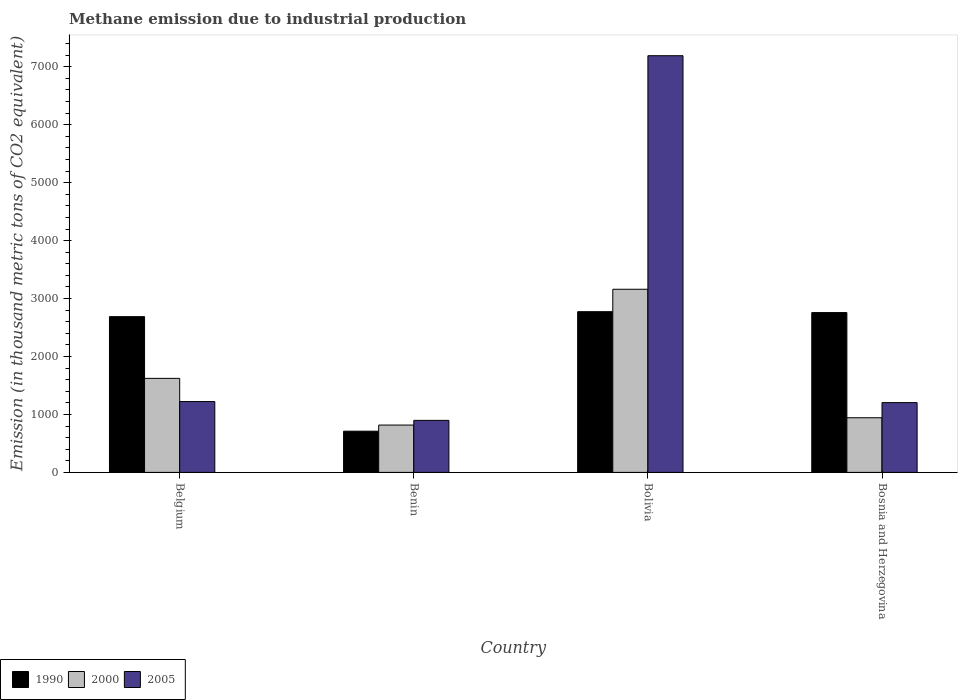How many groups of bars are there?
Your response must be concise. 4. Are the number of bars per tick equal to the number of legend labels?
Provide a short and direct response. Yes. In how many cases, is the number of bars for a given country not equal to the number of legend labels?
Your answer should be very brief. 0. What is the amount of methane emitted in 2000 in Benin?
Provide a succinct answer. 817.2. Across all countries, what is the maximum amount of methane emitted in 2000?
Provide a short and direct response. 3160.9. Across all countries, what is the minimum amount of methane emitted in 1990?
Your response must be concise. 711.4. In which country was the amount of methane emitted in 1990 minimum?
Make the answer very short. Benin. What is the total amount of methane emitted in 2000 in the graph?
Make the answer very short. 6544.3. What is the difference between the amount of methane emitted in 2000 in Benin and that in Bolivia?
Provide a short and direct response. -2343.7. What is the difference between the amount of methane emitted in 2000 in Bosnia and Herzegovina and the amount of methane emitted in 2005 in Benin?
Make the answer very short. 45.1. What is the average amount of methane emitted in 2000 per country?
Make the answer very short. 1636.08. What is the difference between the amount of methane emitted of/in 2000 and amount of methane emitted of/in 2005 in Bosnia and Herzegovina?
Keep it short and to the point. -261.1. In how many countries, is the amount of methane emitted in 1990 greater than 1600 thousand metric tons?
Ensure brevity in your answer.  3. What is the ratio of the amount of methane emitted in 2000 in Belgium to that in Benin?
Your response must be concise. 1.99. Is the amount of methane emitted in 1990 in Benin less than that in Bosnia and Herzegovina?
Your response must be concise. Yes. What is the difference between the highest and the second highest amount of methane emitted in 2000?
Provide a succinct answer. 2217.7. What is the difference between the highest and the lowest amount of methane emitted in 2005?
Make the answer very short. 6293.6. Are all the bars in the graph horizontal?
Offer a very short reply. No. What is the difference between two consecutive major ticks on the Y-axis?
Your answer should be compact. 1000. Are the values on the major ticks of Y-axis written in scientific E-notation?
Make the answer very short. No. Does the graph contain any zero values?
Make the answer very short. No. How many legend labels are there?
Provide a succinct answer. 3. How are the legend labels stacked?
Provide a short and direct response. Horizontal. What is the title of the graph?
Ensure brevity in your answer.  Methane emission due to industrial production. What is the label or title of the X-axis?
Provide a short and direct response. Country. What is the label or title of the Y-axis?
Provide a short and direct response. Emission (in thousand metric tons of CO2 equivalent). What is the Emission (in thousand metric tons of CO2 equivalent) in 1990 in Belgium?
Your answer should be compact. 2688.2. What is the Emission (in thousand metric tons of CO2 equivalent) in 2000 in Belgium?
Your answer should be very brief. 1623. What is the Emission (in thousand metric tons of CO2 equivalent) in 2005 in Belgium?
Provide a short and direct response. 1222.7. What is the Emission (in thousand metric tons of CO2 equivalent) in 1990 in Benin?
Provide a succinct answer. 711.4. What is the Emission (in thousand metric tons of CO2 equivalent) of 2000 in Benin?
Keep it short and to the point. 817.2. What is the Emission (in thousand metric tons of CO2 equivalent) in 2005 in Benin?
Provide a short and direct response. 898.1. What is the Emission (in thousand metric tons of CO2 equivalent) of 1990 in Bolivia?
Offer a very short reply. 2773.8. What is the Emission (in thousand metric tons of CO2 equivalent) of 2000 in Bolivia?
Ensure brevity in your answer.  3160.9. What is the Emission (in thousand metric tons of CO2 equivalent) of 2005 in Bolivia?
Give a very brief answer. 7191.7. What is the Emission (in thousand metric tons of CO2 equivalent) in 1990 in Bosnia and Herzegovina?
Offer a terse response. 2758.5. What is the Emission (in thousand metric tons of CO2 equivalent) of 2000 in Bosnia and Herzegovina?
Make the answer very short. 943.2. What is the Emission (in thousand metric tons of CO2 equivalent) in 2005 in Bosnia and Herzegovina?
Provide a succinct answer. 1204.3. Across all countries, what is the maximum Emission (in thousand metric tons of CO2 equivalent) in 1990?
Your answer should be very brief. 2773.8. Across all countries, what is the maximum Emission (in thousand metric tons of CO2 equivalent) of 2000?
Provide a succinct answer. 3160.9. Across all countries, what is the maximum Emission (in thousand metric tons of CO2 equivalent) of 2005?
Keep it short and to the point. 7191.7. Across all countries, what is the minimum Emission (in thousand metric tons of CO2 equivalent) of 1990?
Your answer should be very brief. 711.4. Across all countries, what is the minimum Emission (in thousand metric tons of CO2 equivalent) in 2000?
Offer a terse response. 817.2. Across all countries, what is the minimum Emission (in thousand metric tons of CO2 equivalent) in 2005?
Ensure brevity in your answer.  898.1. What is the total Emission (in thousand metric tons of CO2 equivalent) of 1990 in the graph?
Your answer should be very brief. 8931.9. What is the total Emission (in thousand metric tons of CO2 equivalent) of 2000 in the graph?
Offer a terse response. 6544.3. What is the total Emission (in thousand metric tons of CO2 equivalent) of 2005 in the graph?
Offer a very short reply. 1.05e+04. What is the difference between the Emission (in thousand metric tons of CO2 equivalent) in 1990 in Belgium and that in Benin?
Make the answer very short. 1976.8. What is the difference between the Emission (in thousand metric tons of CO2 equivalent) in 2000 in Belgium and that in Benin?
Your answer should be compact. 805.8. What is the difference between the Emission (in thousand metric tons of CO2 equivalent) of 2005 in Belgium and that in Benin?
Offer a terse response. 324.6. What is the difference between the Emission (in thousand metric tons of CO2 equivalent) in 1990 in Belgium and that in Bolivia?
Offer a terse response. -85.6. What is the difference between the Emission (in thousand metric tons of CO2 equivalent) of 2000 in Belgium and that in Bolivia?
Give a very brief answer. -1537.9. What is the difference between the Emission (in thousand metric tons of CO2 equivalent) of 2005 in Belgium and that in Bolivia?
Your answer should be compact. -5969. What is the difference between the Emission (in thousand metric tons of CO2 equivalent) of 1990 in Belgium and that in Bosnia and Herzegovina?
Keep it short and to the point. -70.3. What is the difference between the Emission (in thousand metric tons of CO2 equivalent) in 2000 in Belgium and that in Bosnia and Herzegovina?
Give a very brief answer. 679.8. What is the difference between the Emission (in thousand metric tons of CO2 equivalent) of 2005 in Belgium and that in Bosnia and Herzegovina?
Give a very brief answer. 18.4. What is the difference between the Emission (in thousand metric tons of CO2 equivalent) of 1990 in Benin and that in Bolivia?
Make the answer very short. -2062.4. What is the difference between the Emission (in thousand metric tons of CO2 equivalent) of 2000 in Benin and that in Bolivia?
Offer a terse response. -2343.7. What is the difference between the Emission (in thousand metric tons of CO2 equivalent) in 2005 in Benin and that in Bolivia?
Your answer should be compact. -6293.6. What is the difference between the Emission (in thousand metric tons of CO2 equivalent) of 1990 in Benin and that in Bosnia and Herzegovina?
Keep it short and to the point. -2047.1. What is the difference between the Emission (in thousand metric tons of CO2 equivalent) in 2000 in Benin and that in Bosnia and Herzegovina?
Your response must be concise. -126. What is the difference between the Emission (in thousand metric tons of CO2 equivalent) of 2005 in Benin and that in Bosnia and Herzegovina?
Give a very brief answer. -306.2. What is the difference between the Emission (in thousand metric tons of CO2 equivalent) of 2000 in Bolivia and that in Bosnia and Herzegovina?
Ensure brevity in your answer.  2217.7. What is the difference between the Emission (in thousand metric tons of CO2 equivalent) in 2005 in Bolivia and that in Bosnia and Herzegovina?
Keep it short and to the point. 5987.4. What is the difference between the Emission (in thousand metric tons of CO2 equivalent) of 1990 in Belgium and the Emission (in thousand metric tons of CO2 equivalent) of 2000 in Benin?
Offer a terse response. 1871. What is the difference between the Emission (in thousand metric tons of CO2 equivalent) of 1990 in Belgium and the Emission (in thousand metric tons of CO2 equivalent) of 2005 in Benin?
Your answer should be very brief. 1790.1. What is the difference between the Emission (in thousand metric tons of CO2 equivalent) in 2000 in Belgium and the Emission (in thousand metric tons of CO2 equivalent) in 2005 in Benin?
Your answer should be compact. 724.9. What is the difference between the Emission (in thousand metric tons of CO2 equivalent) in 1990 in Belgium and the Emission (in thousand metric tons of CO2 equivalent) in 2000 in Bolivia?
Keep it short and to the point. -472.7. What is the difference between the Emission (in thousand metric tons of CO2 equivalent) of 1990 in Belgium and the Emission (in thousand metric tons of CO2 equivalent) of 2005 in Bolivia?
Provide a short and direct response. -4503.5. What is the difference between the Emission (in thousand metric tons of CO2 equivalent) of 2000 in Belgium and the Emission (in thousand metric tons of CO2 equivalent) of 2005 in Bolivia?
Offer a very short reply. -5568.7. What is the difference between the Emission (in thousand metric tons of CO2 equivalent) of 1990 in Belgium and the Emission (in thousand metric tons of CO2 equivalent) of 2000 in Bosnia and Herzegovina?
Keep it short and to the point. 1745. What is the difference between the Emission (in thousand metric tons of CO2 equivalent) of 1990 in Belgium and the Emission (in thousand metric tons of CO2 equivalent) of 2005 in Bosnia and Herzegovina?
Make the answer very short. 1483.9. What is the difference between the Emission (in thousand metric tons of CO2 equivalent) in 2000 in Belgium and the Emission (in thousand metric tons of CO2 equivalent) in 2005 in Bosnia and Herzegovina?
Keep it short and to the point. 418.7. What is the difference between the Emission (in thousand metric tons of CO2 equivalent) in 1990 in Benin and the Emission (in thousand metric tons of CO2 equivalent) in 2000 in Bolivia?
Keep it short and to the point. -2449.5. What is the difference between the Emission (in thousand metric tons of CO2 equivalent) in 1990 in Benin and the Emission (in thousand metric tons of CO2 equivalent) in 2005 in Bolivia?
Offer a terse response. -6480.3. What is the difference between the Emission (in thousand metric tons of CO2 equivalent) in 2000 in Benin and the Emission (in thousand metric tons of CO2 equivalent) in 2005 in Bolivia?
Your answer should be compact. -6374.5. What is the difference between the Emission (in thousand metric tons of CO2 equivalent) in 1990 in Benin and the Emission (in thousand metric tons of CO2 equivalent) in 2000 in Bosnia and Herzegovina?
Offer a terse response. -231.8. What is the difference between the Emission (in thousand metric tons of CO2 equivalent) in 1990 in Benin and the Emission (in thousand metric tons of CO2 equivalent) in 2005 in Bosnia and Herzegovina?
Keep it short and to the point. -492.9. What is the difference between the Emission (in thousand metric tons of CO2 equivalent) in 2000 in Benin and the Emission (in thousand metric tons of CO2 equivalent) in 2005 in Bosnia and Herzegovina?
Your answer should be very brief. -387.1. What is the difference between the Emission (in thousand metric tons of CO2 equivalent) of 1990 in Bolivia and the Emission (in thousand metric tons of CO2 equivalent) of 2000 in Bosnia and Herzegovina?
Provide a succinct answer. 1830.6. What is the difference between the Emission (in thousand metric tons of CO2 equivalent) in 1990 in Bolivia and the Emission (in thousand metric tons of CO2 equivalent) in 2005 in Bosnia and Herzegovina?
Keep it short and to the point. 1569.5. What is the difference between the Emission (in thousand metric tons of CO2 equivalent) in 2000 in Bolivia and the Emission (in thousand metric tons of CO2 equivalent) in 2005 in Bosnia and Herzegovina?
Your response must be concise. 1956.6. What is the average Emission (in thousand metric tons of CO2 equivalent) of 1990 per country?
Your response must be concise. 2232.97. What is the average Emission (in thousand metric tons of CO2 equivalent) of 2000 per country?
Offer a very short reply. 1636.08. What is the average Emission (in thousand metric tons of CO2 equivalent) in 2005 per country?
Keep it short and to the point. 2629.2. What is the difference between the Emission (in thousand metric tons of CO2 equivalent) in 1990 and Emission (in thousand metric tons of CO2 equivalent) in 2000 in Belgium?
Make the answer very short. 1065.2. What is the difference between the Emission (in thousand metric tons of CO2 equivalent) of 1990 and Emission (in thousand metric tons of CO2 equivalent) of 2005 in Belgium?
Give a very brief answer. 1465.5. What is the difference between the Emission (in thousand metric tons of CO2 equivalent) of 2000 and Emission (in thousand metric tons of CO2 equivalent) of 2005 in Belgium?
Your answer should be very brief. 400.3. What is the difference between the Emission (in thousand metric tons of CO2 equivalent) in 1990 and Emission (in thousand metric tons of CO2 equivalent) in 2000 in Benin?
Keep it short and to the point. -105.8. What is the difference between the Emission (in thousand metric tons of CO2 equivalent) of 1990 and Emission (in thousand metric tons of CO2 equivalent) of 2005 in Benin?
Keep it short and to the point. -186.7. What is the difference between the Emission (in thousand metric tons of CO2 equivalent) of 2000 and Emission (in thousand metric tons of CO2 equivalent) of 2005 in Benin?
Keep it short and to the point. -80.9. What is the difference between the Emission (in thousand metric tons of CO2 equivalent) of 1990 and Emission (in thousand metric tons of CO2 equivalent) of 2000 in Bolivia?
Ensure brevity in your answer.  -387.1. What is the difference between the Emission (in thousand metric tons of CO2 equivalent) of 1990 and Emission (in thousand metric tons of CO2 equivalent) of 2005 in Bolivia?
Your answer should be compact. -4417.9. What is the difference between the Emission (in thousand metric tons of CO2 equivalent) of 2000 and Emission (in thousand metric tons of CO2 equivalent) of 2005 in Bolivia?
Offer a terse response. -4030.8. What is the difference between the Emission (in thousand metric tons of CO2 equivalent) in 1990 and Emission (in thousand metric tons of CO2 equivalent) in 2000 in Bosnia and Herzegovina?
Keep it short and to the point. 1815.3. What is the difference between the Emission (in thousand metric tons of CO2 equivalent) in 1990 and Emission (in thousand metric tons of CO2 equivalent) in 2005 in Bosnia and Herzegovina?
Your answer should be very brief. 1554.2. What is the difference between the Emission (in thousand metric tons of CO2 equivalent) in 2000 and Emission (in thousand metric tons of CO2 equivalent) in 2005 in Bosnia and Herzegovina?
Offer a terse response. -261.1. What is the ratio of the Emission (in thousand metric tons of CO2 equivalent) of 1990 in Belgium to that in Benin?
Ensure brevity in your answer.  3.78. What is the ratio of the Emission (in thousand metric tons of CO2 equivalent) in 2000 in Belgium to that in Benin?
Offer a very short reply. 1.99. What is the ratio of the Emission (in thousand metric tons of CO2 equivalent) in 2005 in Belgium to that in Benin?
Offer a terse response. 1.36. What is the ratio of the Emission (in thousand metric tons of CO2 equivalent) of 1990 in Belgium to that in Bolivia?
Offer a terse response. 0.97. What is the ratio of the Emission (in thousand metric tons of CO2 equivalent) in 2000 in Belgium to that in Bolivia?
Provide a succinct answer. 0.51. What is the ratio of the Emission (in thousand metric tons of CO2 equivalent) in 2005 in Belgium to that in Bolivia?
Your response must be concise. 0.17. What is the ratio of the Emission (in thousand metric tons of CO2 equivalent) of 1990 in Belgium to that in Bosnia and Herzegovina?
Provide a succinct answer. 0.97. What is the ratio of the Emission (in thousand metric tons of CO2 equivalent) in 2000 in Belgium to that in Bosnia and Herzegovina?
Offer a very short reply. 1.72. What is the ratio of the Emission (in thousand metric tons of CO2 equivalent) of 2005 in Belgium to that in Bosnia and Herzegovina?
Keep it short and to the point. 1.02. What is the ratio of the Emission (in thousand metric tons of CO2 equivalent) of 1990 in Benin to that in Bolivia?
Ensure brevity in your answer.  0.26. What is the ratio of the Emission (in thousand metric tons of CO2 equivalent) of 2000 in Benin to that in Bolivia?
Offer a very short reply. 0.26. What is the ratio of the Emission (in thousand metric tons of CO2 equivalent) in 2005 in Benin to that in Bolivia?
Ensure brevity in your answer.  0.12. What is the ratio of the Emission (in thousand metric tons of CO2 equivalent) in 1990 in Benin to that in Bosnia and Herzegovina?
Give a very brief answer. 0.26. What is the ratio of the Emission (in thousand metric tons of CO2 equivalent) of 2000 in Benin to that in Bosnia and Herzegovina?
Your answer should be very brief. 0.87. What is the ratio of the Emission (in thousand metric tons of CO2 equivalent) of 2005 in Benin to that in Bosnia and Herzegovina?
Your answer should be very brief. 0.75. What is the ratio of the Emission (in thousand metric tons of CO2 equivalent) of 1990 in Bolivia to that in Bosnia and Herzegovina?
Keep it short and to the point. 1.01. What is the ratio of the Emission (in thousand metric tons of CO2 equivalent) in 2000 in Bolivia to that in Bosnia and Herzegovina?
Your answer should be compact. 3.35. What is the ratio of the Emission (in thousand metric tons of CO2 equivalent) of 2005 in Bolivia to that in Bosnia and Herzegovina?
Your answer should be very brief. 5.97. What is the difference between the highest and the second highest Emission (in thousand metric tons of CO2 equivalent) of 1990?
Your answer should be very brief. 15.3. What is the difference between the highest and the second highest Emission (in thousand metric tons of CO2 equivalent) in 2000?
Your response must be concise. 1537.9. What is the difference between the highest and the second highest Emission (in thousand metric tons of CO2 equivalent) in 2005?
Provide a short and direct response. 5969. What is the difference between the highest and the lowest Emission (in thousand metric tons of CO2 equivalent) of 1990?
Your answer should be compact. 2062.4. What is the difference between the highest and the lowest Emission (in thousand metric tons of CO2 equivalent) of 2000?
Your answer should be compact. 2343.7. What is the difference between the highest and the lowest Emission (in thousand metric tons of CO2 equivalent) in 2005?
Provide a short and direct response. 6293.6. 